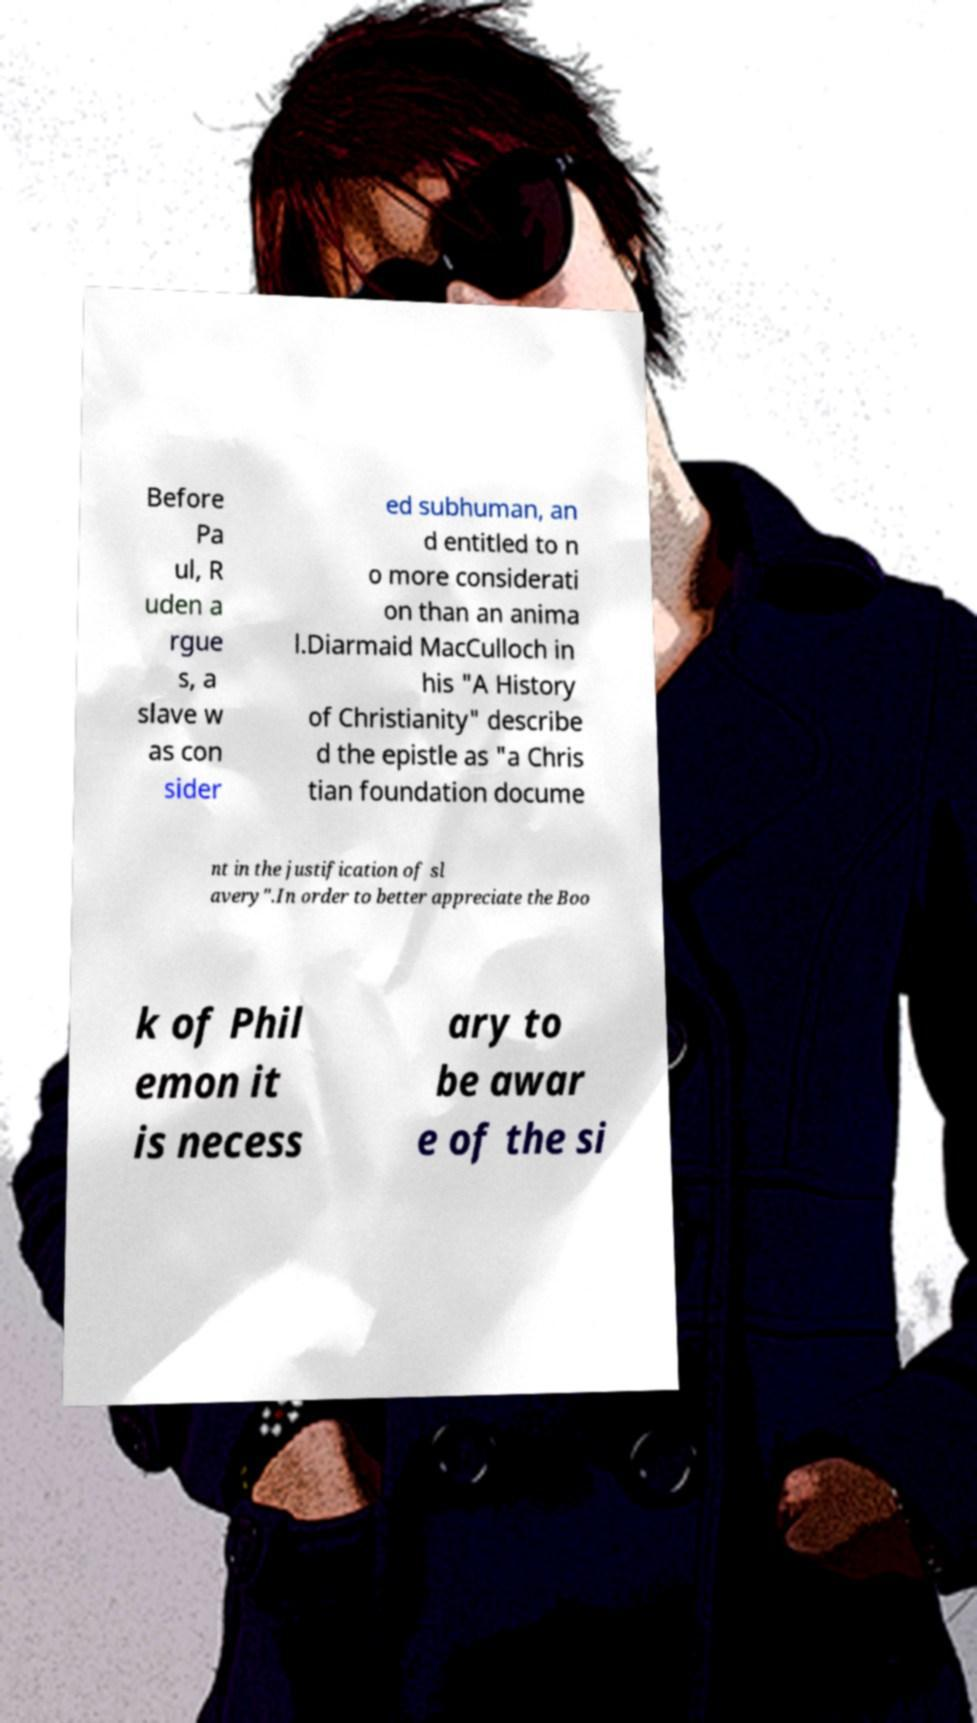Could you extract and type out the text from this image? Before Pa ul, R uden a rgue s, a slave w as con sider ed subhuman, an d entitled to n o more considerati on than an anima l.Diarmaid MacCulloch in his "A History of Christianity" describe d the epistle as "a Chris tian foundation docume nt in the justification of sl avery".In order to better appreciate the Boo k of Phil emon it is necess ary to be awar e of the si 